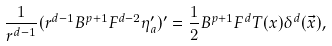Convert formula to latex. <formula><loc_0><loc_0><loc_500><loc_500>\frac { 1 } { r ^ { d - 1 } } ( r ^ { d - 1 } B ^ { p + 1 } F ^ { d - 2 } \eta _ { a } ^ { \prime } ) ^ { \prime } = \frac { 1 } { 2 } B ^ { p + 1 } F ^ { d } T ( x ) \delta ^ { d } ( \vec { x } ) ,</formula> 